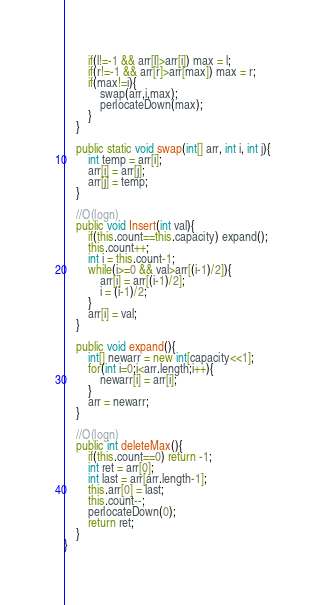<code> <loc_0><loc_0><loc_500><loc_500><_Java_>        if(l!=-1 && arr[l]>arr[i]) max = l;
        if(r!=-1 && arr[r]>arr[max]) max = r;
        if(max!=i){
            swap(arr,i,max);
            perlocateDown(max);
        }
    }

    public static void swap(int[] arr, int i, int j){
        int temp = arr[i];
        arr[i] = arr[j];
        arr[j] = temp;
    }

    //O(logn)
    public void Insert(int val){
        if(this.count==this.capacity) expand();
        this.count++;
        int i = this.count-1;
        while(i>=0 && val>arr[(i-1)/2]){
            arr[i] = arr[(i-1)/2];
            i = (i-1)/2;
        }
        arr[i] = val;
    }

    public void expand(){
        int[] newarr = new int[capacity<<1];
        for(int i=0;i<arr.length;i++){
            newarr[i] = arr[i];
        }
        arr = newarr;
    }

    //O(logn)
    public int deleteMax(){
        if(this.count==0) return -1;
        int ret = arr[0];
        int last = arr[arr.length-1];
        this.arr[0] = last;
        this.count--;
        perlocateDown(0);
        return ret;
    }
}
</code> 